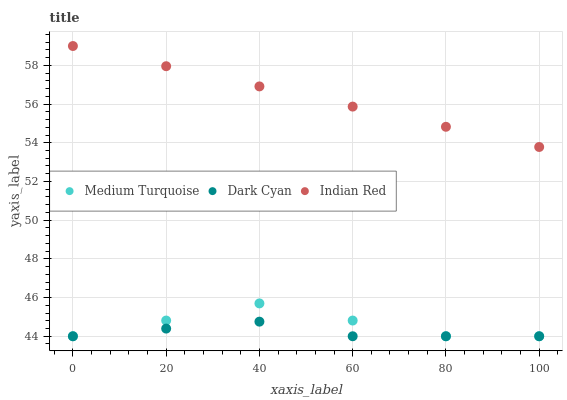Does Dark Cyan have the minimum area under the curve?
Answer yes or no. Yes. Does Indian Red have the maximum area under the curve?
Answer yes or no. Yes. Does Medium Turquoise have the minimum area under the curve?
Answer yes or no. No. Does Medium Turquoise have the maximum area under the curve?
Answer yes or no. No. Is Indian Red the smoothest?
Answer yes or no. Yes. Is Medium Turquoise the roughest?
Answer yes or no. Yes. Is Medium Turquoise the smoothest?
Answer yes or no. No. Is Indian Red the roughest?
Answer yes or no. No. Does Dark Cyan have the lowest value?
Answer yes or no. Yes. Does Indian Red have the lowest value?
Answer yes or no. No. Does Indian Red have the highest value?
Answer yes or no. Yes. Does Medium Turquoise have the highest value?
Answer yes or no. No. Is Dark Cyan less than Indian Red?
Answer yes or no. Yes. Is Indian Red greater than Dark Cyan?
Answer yes or no. Yes. Does Dark Cyan intersect Medium Turquoise?
Answer yes or no. Yes. Is Dark Cyan less than Medium Turquoise?
Answer yes or no. No. Is Dark Cyan greater than Medium Turquoise?
Answer yes or no. No. Does Dark Cyan intersect Indian Red?
Answer yes or no. No. 